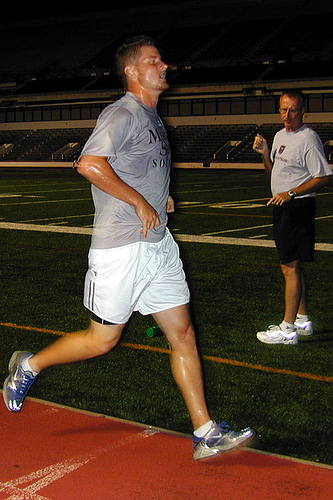<image>
Is there a man above the ground? Yes. The man is positioned above the ground in the vertical space, higher up in the scene. 